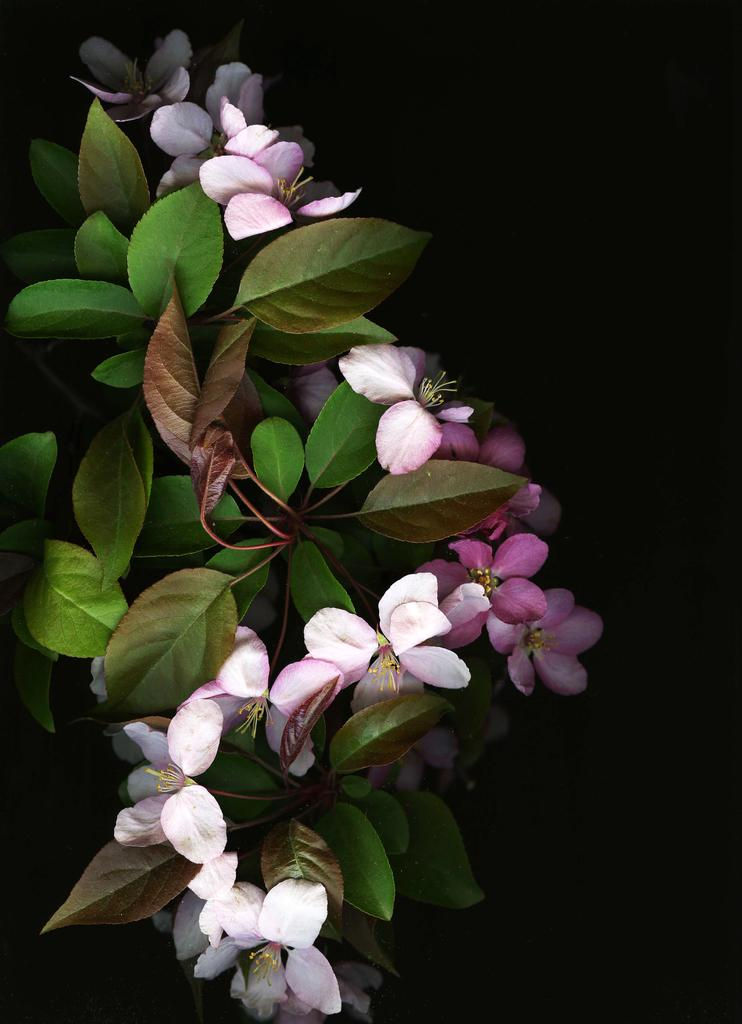What type of plant is visible in the image? There is a plant with flowers in the image. What can be observed about the background of the image? The background of the image is dark. How many eyes can be seen on the plant in the image? There are no eyes visible on the plant in the image, as plants do not have eyes. 